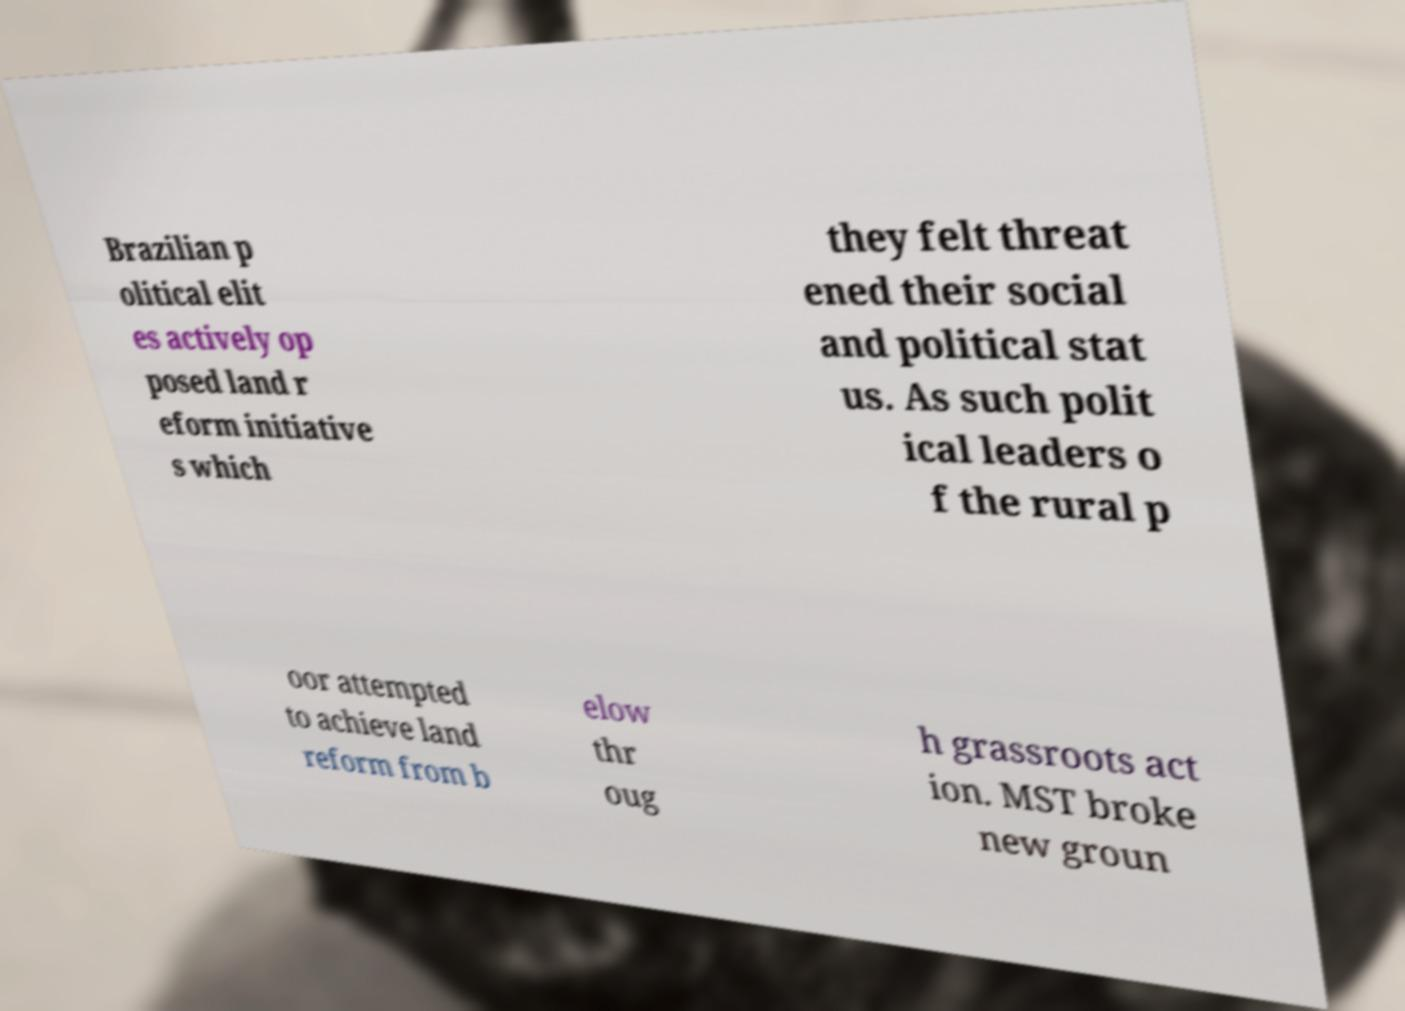Can you accurately transcribe the text from the provided image for me? Brazilian p olitical elit es actively op posed land r eform initiative s which they felt threat ened their social and political stat us. As such polit ical leaders o f the rural p oor attempted to achieve land reform from b elow thr oug h grassroots act ion. MST broke new groun 